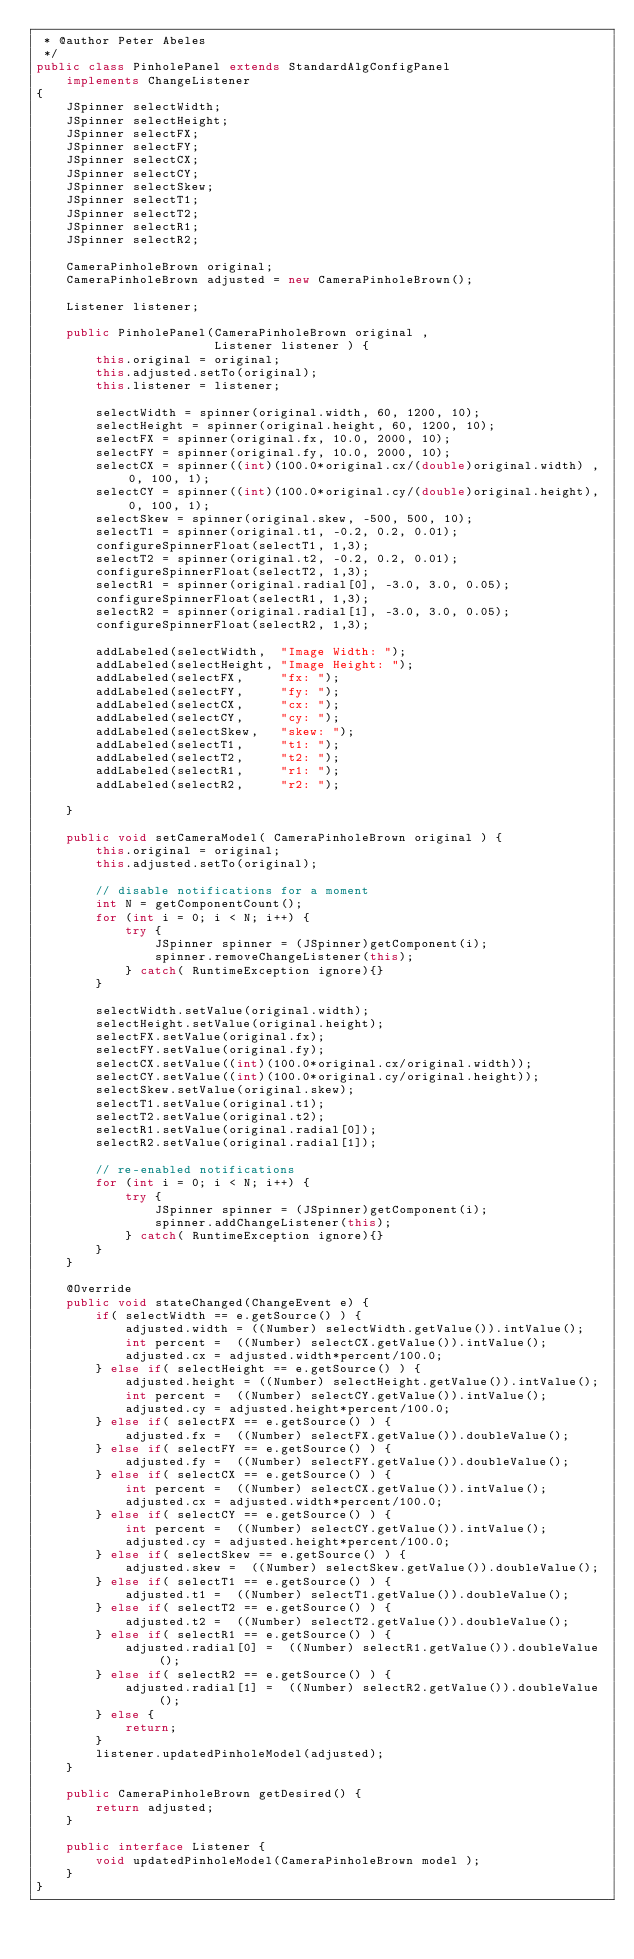Convert code to text. <code><loc_0><loc_0><loc_500><loc_500><_Java_> * @author Peter Abeles
 */
public class PinholePanel extends StandardAlgConfigPanel
	implements ChangeListener
{
	JSpinner selectWidth;
	JSpinner selectHeight;
	JSpinner selectFX;
	JSpinner selectFY;
	JSpinner selectCX;
	JSpinner selectCY;
	JSpinner selectSkew;
	JSpinner selectT1;
	JSpinner selectT2;
	JSpinner selectR1;
	JSpinner selectR2;

	CameraPinholeBrown original;
	CameraPinholeBrown adjusted = new CameraPinholeBrown();

	Listener listener;

	public PinholePanel(CameraPinholeBrown original ,
						Listener listener ) {
		this.original = original;
		this.adjusted.setTo(original);
		this.listener = listener;

		selectWidth = spinner(original.width, 60, 1200, 10);
		selectHeight = spinner(original.height, 60, 1200, 10);
		selectFX = spinner(original.fx, 10.0, 2000, 10);
		selectFY = spinner(original.fy, 10.0, 2000, 10);
		selectCX = spinner((int)(100.0*original.cx/(double)original.width) , 0, 100, 1);
		selectCY = spinner((int)(100.0*original.cy/(double)original.height), 0, 100, 1);
		selectSkew = spinner(original.skew, -500, 500, 10);
		selectT1 = spinner(original.t1, -0.2, 0.2, 0.01);
		configureSpinnerFloat(selectT1, 1,3);
		selectT2 = spinner(original.t2, -0.2, 0.2, 0.01);
		configureSpinnerFloat(selectT2, 1,3);
		selectR1 = spinner(original.radial[0], -3.0, 3.0, 0.05);
		configureSpinnerFloat(selectR1, 1,3);
		selectR2 = spinner(original.radial[1], -3.0, 3.0, 0.05);
		configureSpinnerFloat(selectR2, 1,3);

		addLabeled(selectWidth,  "Image Width: ");
		addLabeled(selectHeight, "Image Height: ");
		addLabeled(selectFX,     "fx: ");
		addLabeled(selectFY,     "fy: ");
		addLabeled(selectCX,     "cx: ");
		addLabeled(selectCY,     "cy: ");
		addLabeled(selectSkew,   "skew: ");
		addLabeled(selectT1,     "t1: ");
		addLabeled(selectT2,     "t2: ");
		addLabeled(selectR1,     "r1: ");
		addLabeled(selectR2,     "r2: ");

	}

	public void setCameraModel( CameraPinholeBrown original ) {
		this.original = original;
		this.adjusted.setTo(original);

		// disable notifications for a moment
		int N = getComponentCount();
		for (int i = 0; i < N; i++) {
			try {
				JSpinner spinner = (JSpinner)getComponent(i);
				spinner.removeChangeListener(this);
			} catch( RuntimeException ignore){}
		}

		selectWidth.setValue(original.width);
		selectHeight.setValue(original.height);
		selectFX.setValue(original.fx);
		selectFY.setValue(original.fy);
		selectCX.setValue((int)(100.0*original.cx/original.width));
		selectCY.setValue((int)(100.0*original.cy/original.height));
		selectSkew.setValue(original.skew);
		selectT1.setValue(original.t1);
		selectT2.setValue(original.t2);
		selectR1.setValue(original.radial[0]);
		selectR2.setValue(original.radial[1]);

		// re-enabled notifications
		for (int i = 0; i < N; i++) {
			try {
				JSpinner spinner = (JSpinner)getComponent(i);
				spinner.addChangeListener(this);
			} catch( RuntimeException ignore){}
		}
	}

	@Override
	public void stateChanged(ChangeEvent e) {
		if( selectWidth == e.getSource() ) {
			adjusted.width = ((Number) selectWidth.getValue()).intValue();
			int percent =  ((Number) selectCX.getValue()).intValue();
			adjusted.cx = adjusted.width*percent/100.0;
		} else if( selectHeight == e.getSource() ) {
			adjusted.height = ((Number) selectHeight.getValue()).intValue();
			int percent =  ((Number) selectCY.getValue()).intValue();
			adjusted.cy = adjusted.height*percent/100.0;
		} else if( selectFX == e.getSource() ) {
			adjusted.fx =  ((Number) selectFX.getValue()).doubleValue();
		} else if( selectFY == e.getSource() ) {
			adjusted.fy =  ((Number) selectFY.getValue()).doubleValue();
		} else if( selectCX == e.getSource() ) {
			int percent =  ((Number) selectCX.getValue()).intValue();
			adjusted.cx = adjusted.width*percent/100.0;
		} else if( selectCY == e.getSource() ) {
			int percent =  ((Number) selectCY.getValue()).intValue();
			adjusted.cy = adjusted.height*percent/100.0;
		} else if( selectSkew == e.getSource() ) {
			adjusted.skew =  ((Number) selectSkew.getValue()).doubleValue();
		} else if( selectT1 == e.getSource() ) {
			adjusted.t1 =  ((Number) selectT1.getValue()).doubleValue();
		} else if( selectT2 == e.getSource() ) {
			adjusted.t2 =  ((Number) selectT2.getValue()).doubleValue();
		} else if( selectR1 == e.getSource() ) {
			adjusted.radial[0] =  ((Number) selectR1.getValue()).doubleValue();
		} else if( selectR2 == e.getSource() ) {
			adjusted.radial[1] =  ((Number) selectR2.getValue()).doubleValue();
		} else {
			return;
		}
		listener.updatedPinholeModel(adjusted);
	}

	public CameraPinholeBrown getDesired() {
		return adjusted;
	}

	public interface Listener {
		void updatedPinholeModel(CameraPinholeBrown model );
	}
}
</code> 